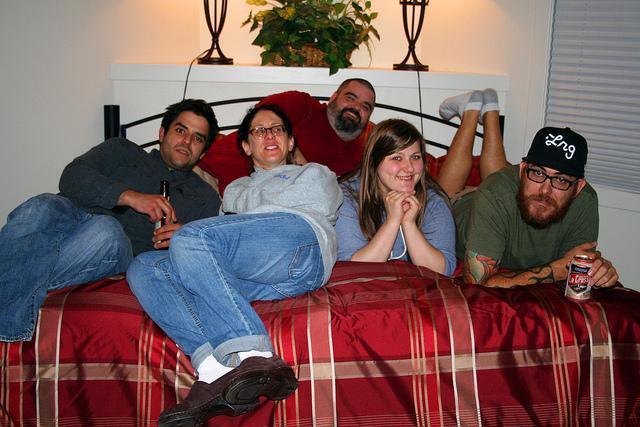How many people are on the bed?
Give a very brief answer. 5. How many feet can you see in this picture?
Give a very brief answer. 4. How many people can you see?
Give a very brief answer. 5. How many beds are in the picture?
Give a very brief answer. 1. 